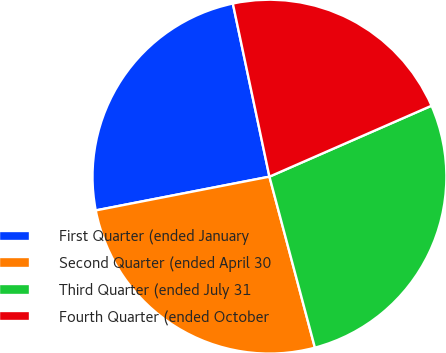<chart> <loc_0><loc_0><loc_500><loc_500><pie_chart><fcel>First Quarter (ended January<fcel>Second Quarter (ended April 30<fcel>Third Quarter (ended July 31<fcel>Fourth Quarter (ended October<nl><fcel>24.74%<fcel>26.08%<fcel>27.43%<fcel>21.75%<nl></chart> 